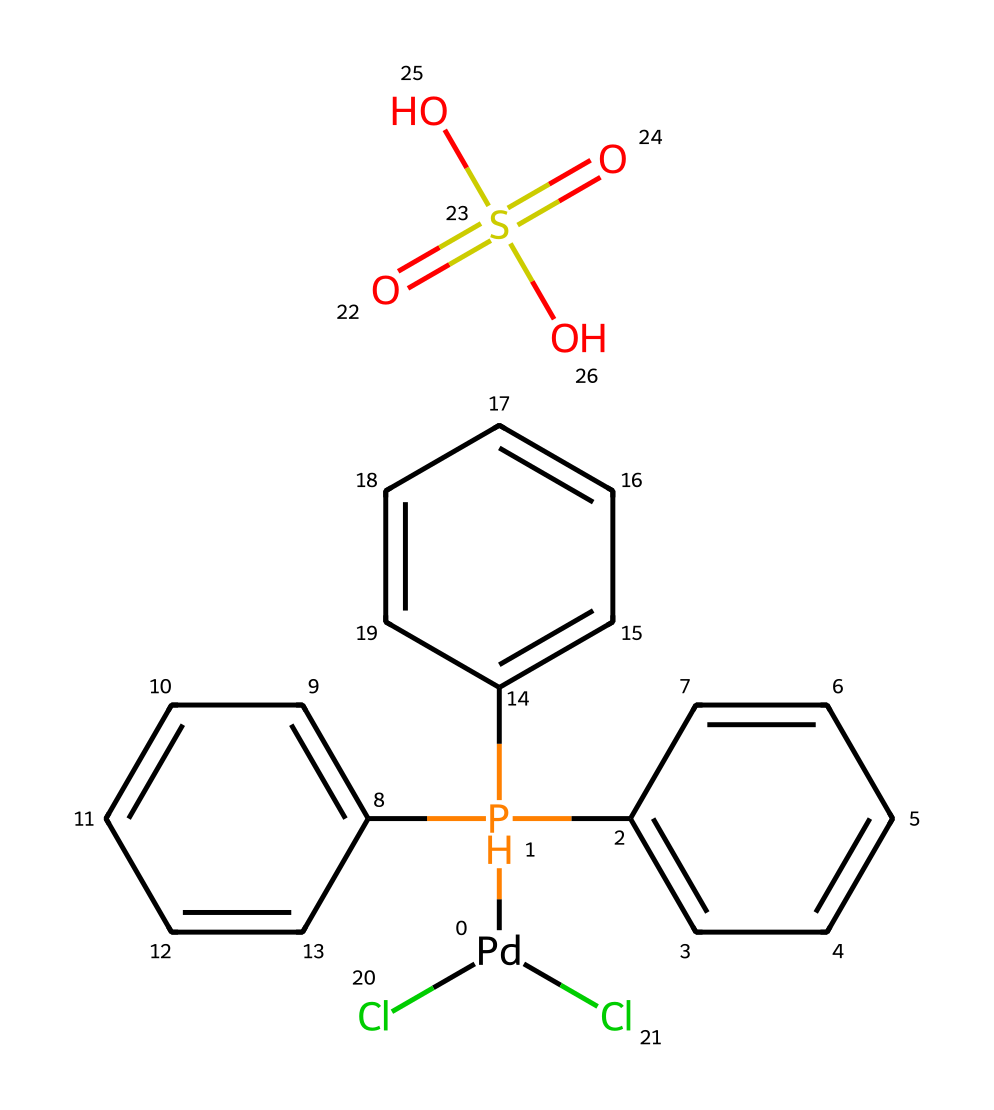What is the metal center in this organometallic compound? The metal center is indicated by the symbol "Pd" in the SMILES representation, which represents palladium.
Answer: palladium How many chlorine atoms are present in this compound? The SMILES notation shows "Cl" twice, indicating that there are two chlorine atoms in the molecular structure.
Answer: two What functional groups are present in this chemical structure? The functional groups include an organophosphate group (due to the presence of phosphorus connected to alkyl groups), and a sulfonic acid group (indicated by "O=S(=O)(O)O").
Answer: organophosphate and sulfonic acid How many aromatic rings can be identified in the structure? Counting the cyclic structures in the chemical, we find three distinct benzene rings. Each one is denoted by the presence of the C=C bonds in a cyclic structure.
Answer: three What is the oxidation state of palladium in this compound? In this structure, palladium is connected to two chlorides, indicating it is in the +2 oxidation state as it typically has a zero oxidation state in its elemental form.
Answer: +2 What role does the sulfonate group play in this organometallic compound? The sulfonate group enhances solubility in polar solvents and can facilitate substrate interactions in catalysis, acting as a leaving group or stabilizer.
Answer: enhances solubility and facilitates catalysis 